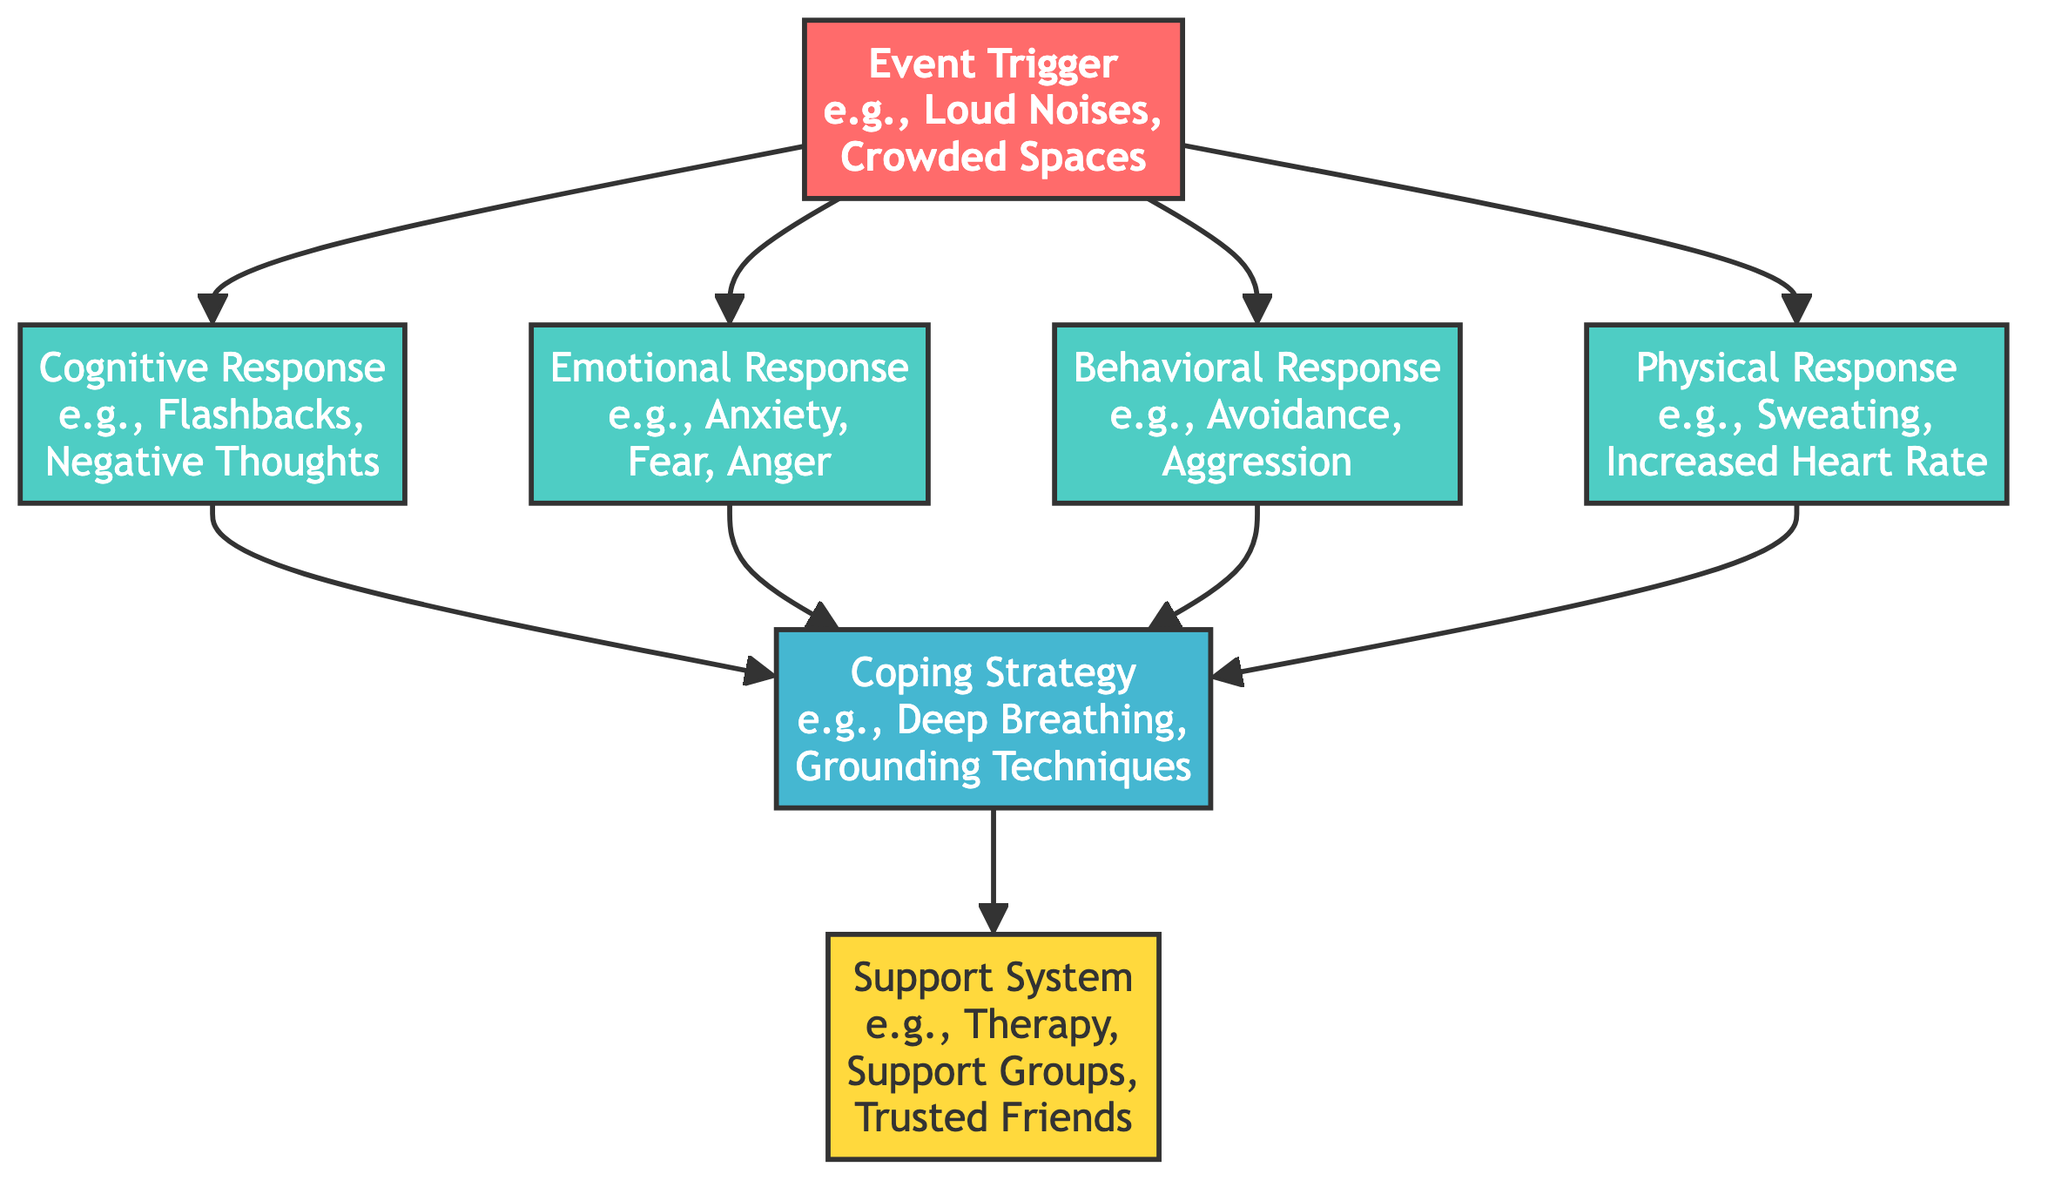What are two examples of event triggers? The diagram shows "Loud Noises" and "Crowded Spaces" as examples under the "Event Trigger" node.
Answer: Loud Noises, Crowded Spaces What type of response is characterized by anxiety and fear? The diagram indicates that "Anxiety" and "Fear" fall under the "Emotional Response" category.
Answer: Emotional Response Which coping strategy is linked to all types of responses? The diagram shows that the "Coping Strategy" node is connected to "Cognitive Response," "Emotional Response," "Behavioral Response," and "Physical Response," indicating it is a common response strategy.
Answer: Coping Strategy How many types of responses are displayed in the diagram? There are four types of responses listed: "Cognitive Response," "Emotional Response," "Behavioral Response," and "Physical Response," which totals to four.
Answer: Four What connects the event trigger to the coping strategy? The arrows in the diagram point from "Event Trigger" to the nodes of different responses, which then connect to the "Coping Strategy" node, showing a progression from trigger to strategy.
Answer: Responses Which node represents the support system? The "Support System" node is labeled explicitly in the diagram with details about support options such as "Therapy," "Support Groups," and "Trusted Friends."
Answer: Support System What is the total number of nodes in the diagram? Counting all the distinct nodes: Event Trigger, Cognitive Response, Emotional Response, Behavioral Response, Physical Response, Coping Strategy, and Support System gives a total of seven nodes.
Answer: Seven What two responses are associated with cognitive response? The cognitive response is linked to the coping strategy, suggesting that both "Cognitive Response" and "Coping Strategy" relate to anxiety and flashbacks based on their connection.
Answer: Coping Strategy What color represents the coping strategy in the diagram? The coping strategy is represented with a blue fill in the diagram, labeled under "Coping Strategy."
Answer: Blue 